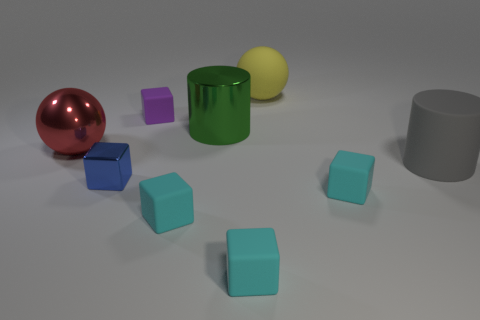Subtract all yellow cylinders. How many cyan blocks are left? 3 Subtract all shiny cubes. How many cubes are left? 4 Subtract all purple cubes. How many cubes are left? 4 Subtract all red blocks. Subtract all brown cylinders. How many blocks are left? 5 Add 1 tiny yellow things. How many objects exist? 10 Subtract all cylinders. How many objects are left? 7 Add 6 big blue metallic cylinders. How many big blue metallic cylinders exist? 6 Subtract 0 brown cylinders. How many objects are left? 9 Subtract all large yellow matte things. Subtract all gray matte objects. How many objects are left? 7 Add 1 small blue metal things. How many small blue metal things are left? 2 